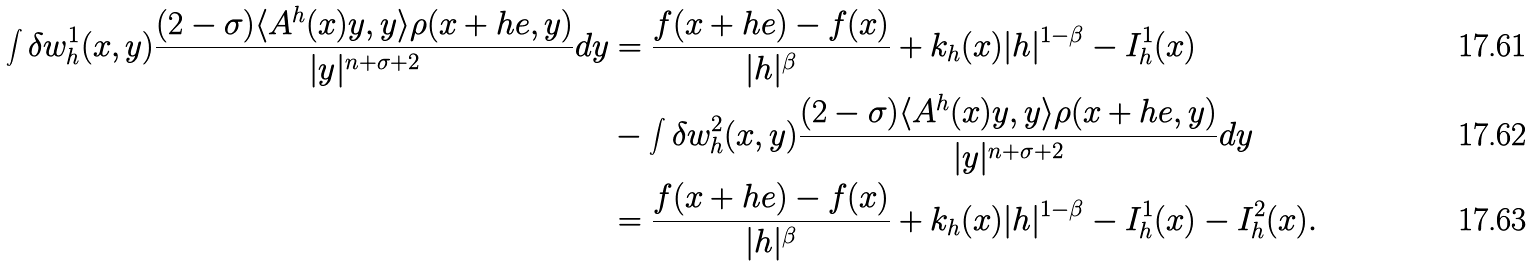Convert formula to latex. <formula><loc_0><loc_0><loc_500><loc_500>\int \delta w ^ { 1 } _ { h } ( x , y ) \frac { ( 2 - \sigma ) \langle A ^ { h } ( x ) y , y \rangle \rho ( x + h e , y ) } { | y | ^ { n + \sigma + 2 } } d y & = \frac { f ( x + h e ) - f ( x ) } { | h | ^ { \beta } } + k _ { h } ( x ) | h | ^ { 1 - \beta } - I ^ { 1 } _ { h } ( x ) \\ & - \int \delta w ^ { 2 } _ { h } ( x , y ) \frac { ( 2 - \sigma ) \langle A ^ { h } ( x ) y , y \rangle \rho ( x + h e , y ) } { | y | ^ { n + \sigma + 2 } } d y \\ & = \frac { f ( x + h e ) - f ( x ) } { | h | ^ { \beta } } + k _ { h } ( x ) | h | ^ { 1 - \beta } - I ^ { 1 } _ { h } ( x ) - I ^ { 2 } _ { h } ( x ) .</formula> 